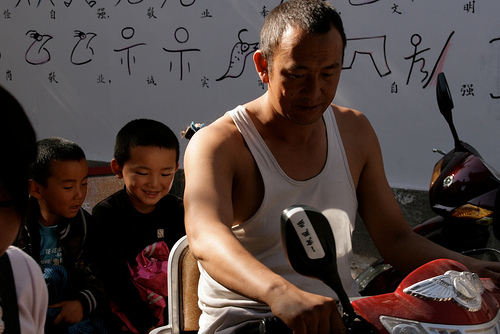<image>
Is there a person on the bike? No. The person is not positioned on the bike. They may be near each other, but the person is not supported by or resting on top of the bike. 